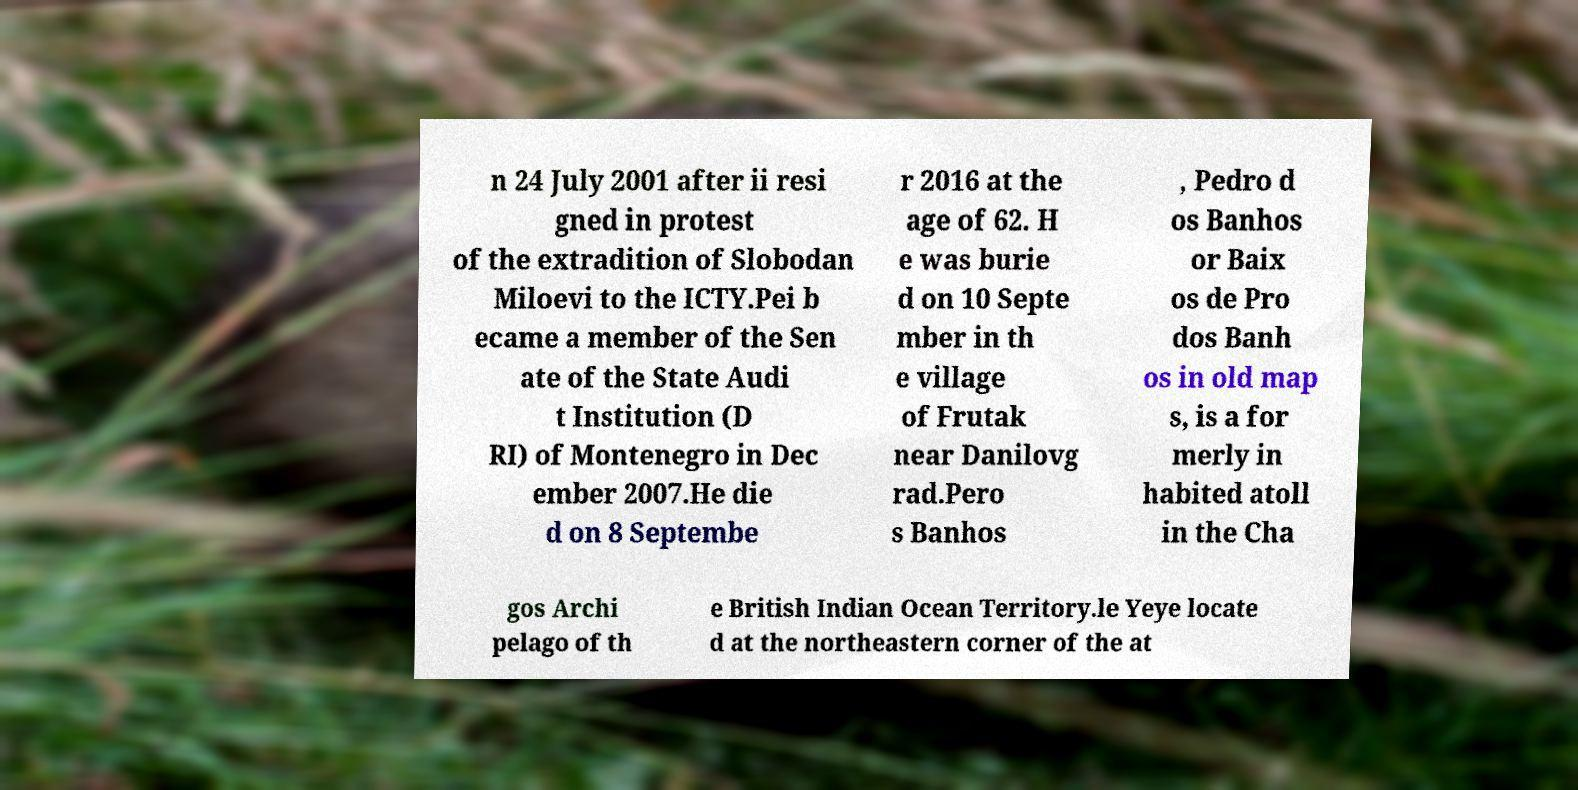Can you read and provide the text displayed in the image?This photo seems to have some interesting text. Can you extract and type it out for me? n 24 July 2001 after ii resi gned in protest of the extradition of Slobodan Miloevi to the ICTY.Pei b ecame a member of the Sen ate of the State Audi t Institution (D RI) of Montenegro in Dec ember 2007.He die d on 8 Septembe r 2016 at the age of 62. H e was burie d on 10 Septe mber in th e village of Frutak near Danilovg rad.Pero s Banhos , Pedro d os Banhos or Baix os de Pro dos Banh os in old map s, is a for merly in habited atoll in the Cha gos Archi pelago of th e British Indian Ocean Territory.le Yeye locate d at the northeastern corner of the at 